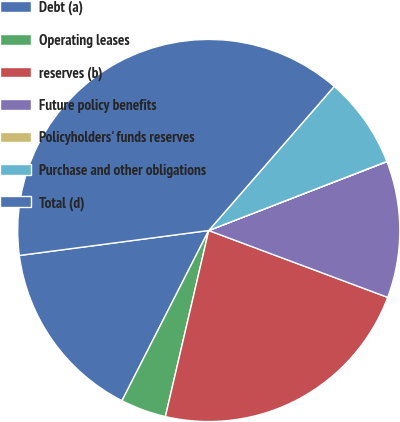<chart> <loc_0><loc_0><loc_500><loc_500><pie_chart><fcel>Debt (a)<fcel>Operating leases<fcel>reserves (b)<fcel>Future policy benefits<fcel>Policyholders' funds reserves<fcel>Purchase and other obligations<fcel>Total (d)<nl><fcel>15.41%<fcel>3.86%<fcel>22.95%<fcel>11.56%<fcel>0.02%<fcel>7.71%<fcel>38.49%<nl></chart> 